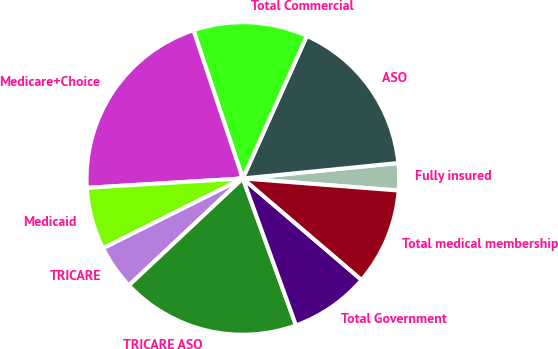Convert chart to OTSL. <chart><loc_0><loc_0><loc_500><loc_500><pie_chart><fcel>Fully insured<fcel>ASO<fcel>Total Commercial<fcel>Medicare+Choice<fcel>Medicaid<fcel>TRICARE<fcel>TRICARE ASO<fcel>Total Government<fcel>Total medical membership<nl><fcel>2.81%<fcel>16.71%<fcel>11.83%<fcel>20.84%<fcel>6.42%<fcel>4.62%<fcel>18.53%<fcel>8.22%<fcel>10.02%<nl></chart> 